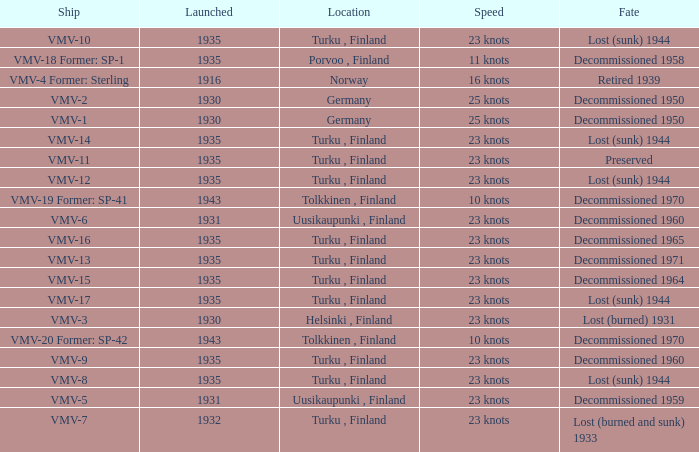Parse the full table. {'header': ['Ship', 'Launched', 'Location', 'Speed', 'Fate'], 'rows': [['VMV-10', '1935', 'Turku , Finland', '23 knots', 'Lost (sunk) 1944'], ['VMV-18 Former: SP-1', '1935', 'Porvoo , Finland', '11 knots', 'Decommissioned 1958'], ['VMV-4 Former: Sterling', '1916', 'Norway', '16 knots', 'Retired 1939'], ['VMV-2', '1930', 'Germany', '25 knots', 'Decommissioned 1950'], ['VMV-1', '1930', 'Germany', '25 knots', 'Decommissioned 1950'], ['VMV-14', '1935', 'Turku , Finland', '23 knots', 'Lost (sunk) 1944'], ['VMV-11', '1935', 'Turku , Finland', '23 knots', 'Preserved'], ['VMV-12', '1935', 'Turku , Finland', '23 knots', 'Lost (sunk) 1944'], ['VMV-19 Former: SP-41', '1943', 'Tolkkinen , Finland', '10 knots', 'Decommissioned 1970'], ['VMV-6', '1931', 'Uusikaupunki , Finland', '23 knots', 'Decommissioned 1960'], ['VMV-16', '1935', 'Turku , Finland', '23 knots', 'Decommissioned 1965'], ['VMV-13', '1935', 'Turku , Finland', '23 knots', 'Decommissioned 1971'], ['VMV-15', '1935', 'Turku , Finland', '23 knots', 'Decommissioned 1964'], ['VMV-17', '1935', 'Turku , Finland', '23 knots', 'Lost (sunk) 1944'], ['VMV-3', '1930', 'Helsinki , Finland', '23 knots', 'Lost (burned) 1931'], ['VMV-20 Former: SP-42', '1943', 'Tolkkinen , Finland', '10 knots', 'Decommissioned 1970'], ['VMV-9', '1935', 'Turku , Finland', '23 knots', 'Decommissioned 1960'], ['VMV-8', '1935', 'Turku , Finland', '23 knots', 'Lost (sunk) 1944'], ['VMV-5', '1931', 'Uusikaupunki , Finland', '23 knots', 'Decommissioned 1959'], ['VMV-7', '1932', 'Turku , Finland', '23 knots', 'Lost (burned and sunk) 1933']]} What is the average launch date of the vmv-1 vessel in Germany? 1930.0. 